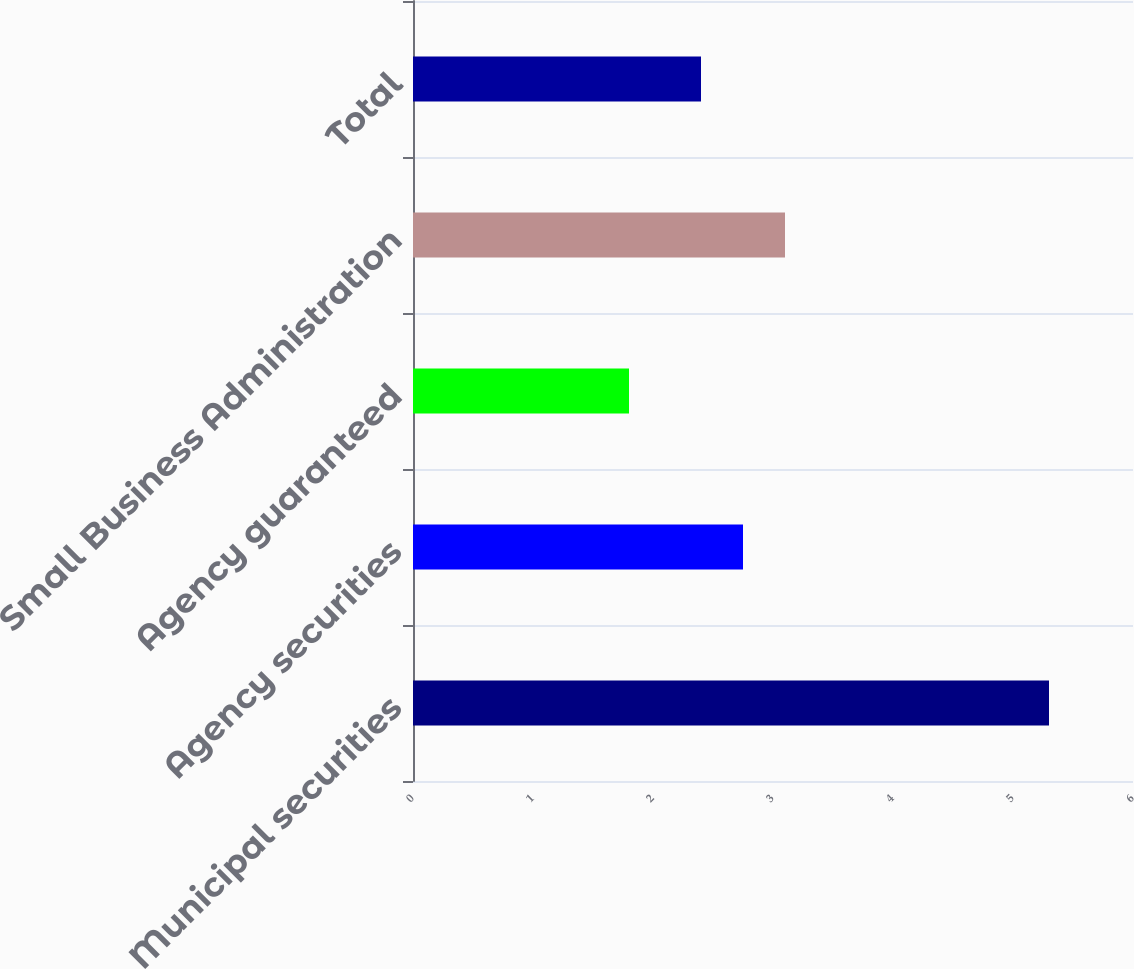Convert chart to OTSL. <chart><loc_0><loc_0><loc_500><loc_500><bar_chart><fcel>Municipal securities<fcel>Agency securities<fcel>Agency guaranteed<fcel>Small Business Administration<fcel>Total<nl><fcel>5.3<fcel>2.75<fcel>1.8<fcel>3.1<fcel>2.4<nl></chart> 